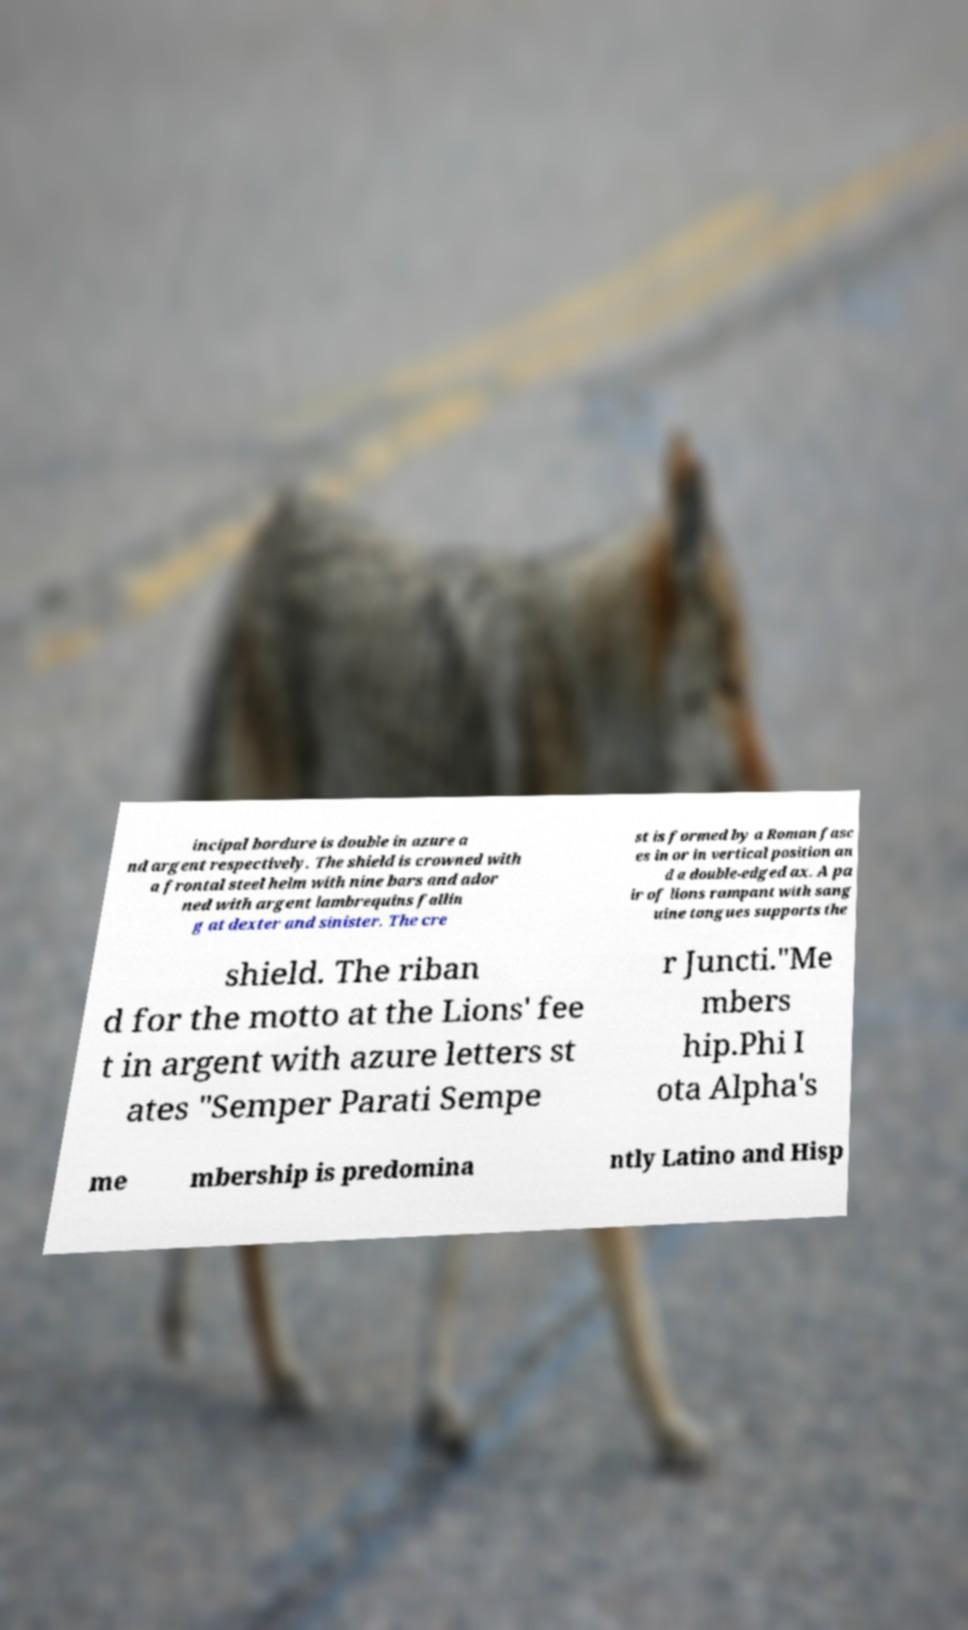Could you assist in decoding the text presented in this image and type it out clearly? incipal bordure is double in azure a nd argent respectively. The shield is crowned with a frontal steel helm with nine bars and ador ned with argent lambrequins fallin g at dexter and sinister. The cre st is formed by a Roman fasc es in or in vertical position an d a double-edged ax. A pa ir of lions rampant with sang uine tongues supports the shield. The riban d for the motto at the Lions' fee t in argent with azure letters st ates "Semper Parati Sempe r Juncti."Me mbers hip.Phi I ota Alpha's me mbership is predomina ntly Latino and Hisp 